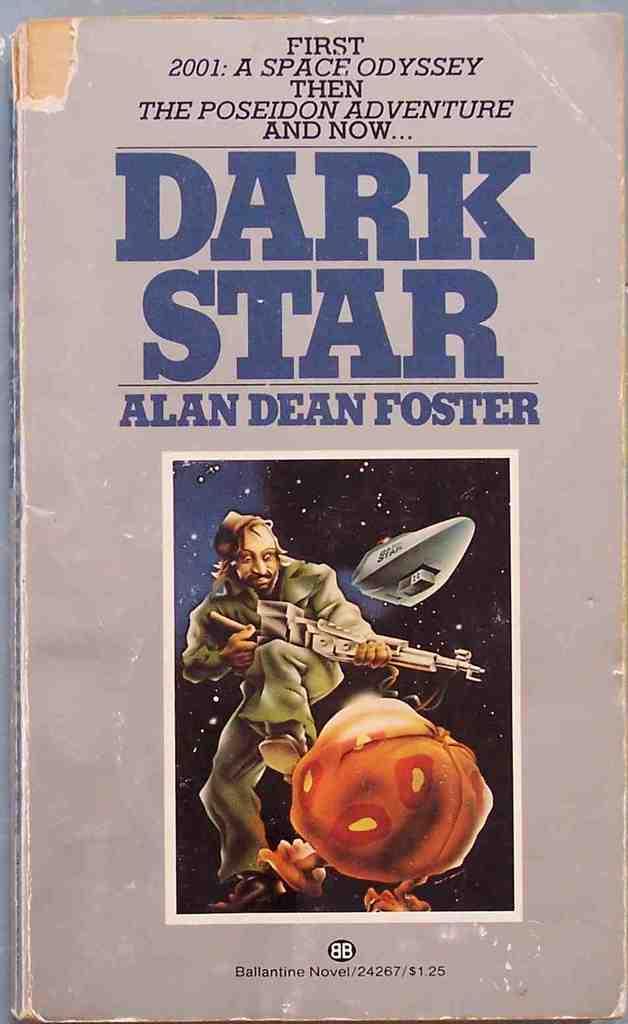What is the price of this book?
Offer a very short reply. 1.25. Who is the author of this book?
Your response must be concise. Alan dean foster. 